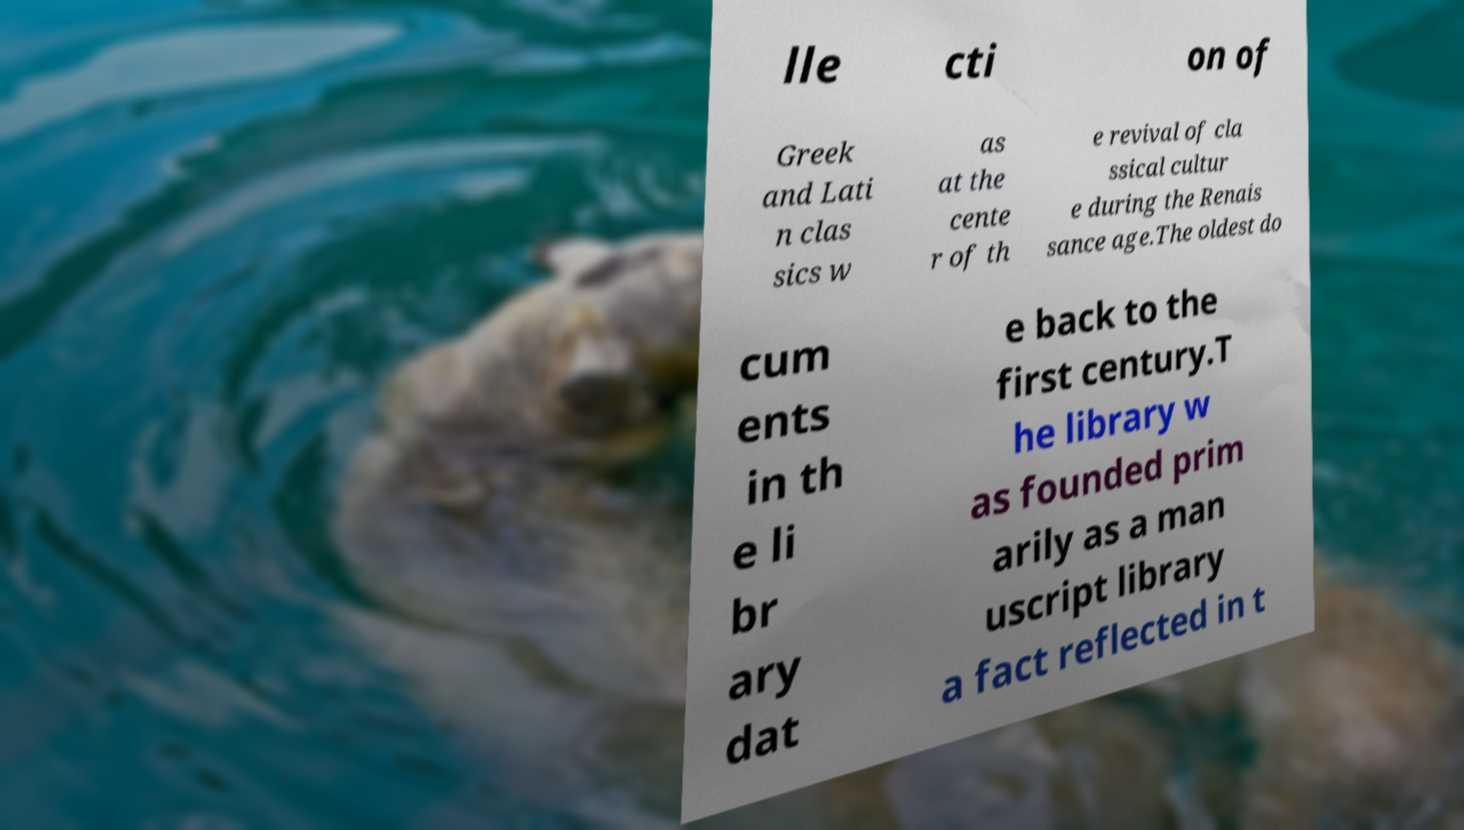Could you assist in decoding the text presented in this image and type it out clearly? lle cti on of Greek and Lati n clas sics w as at the cente r of th e revival of cla ssical cultur e during the Renais sance age.The oldest do cum ents in th e li br ary dat e back to the first century.T he library w as founded prim arily as a man uscript library a fact reflected in t 